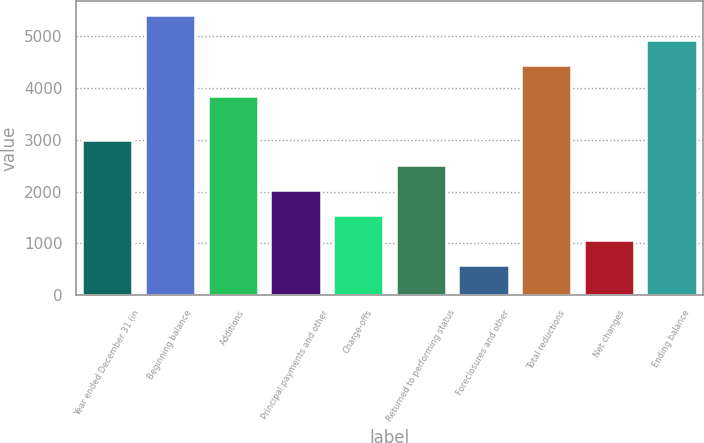Convert chart. <chart><loc_0><loc_0><loc_500><loc_500><bar_chart><fcel>Year ended December 31 (in<fcel>Beginning balance<fcel>Additions<fcel>Principal payments and other<fcel>Charge-offs<fcel>Returned to performing status<fcel>Foreclosures and other<fcel>Total reductions<fcel>Net changes<fcel>Ending balance<nl><fcel>2997.5<fcel>5417.2<fcel>3858<fcel>2031.3<fcel>1548.2<fcel>2514.4<fcel>582<fcel>4451<fcel>1065.1<fcel>4934.1<nl></chart> 